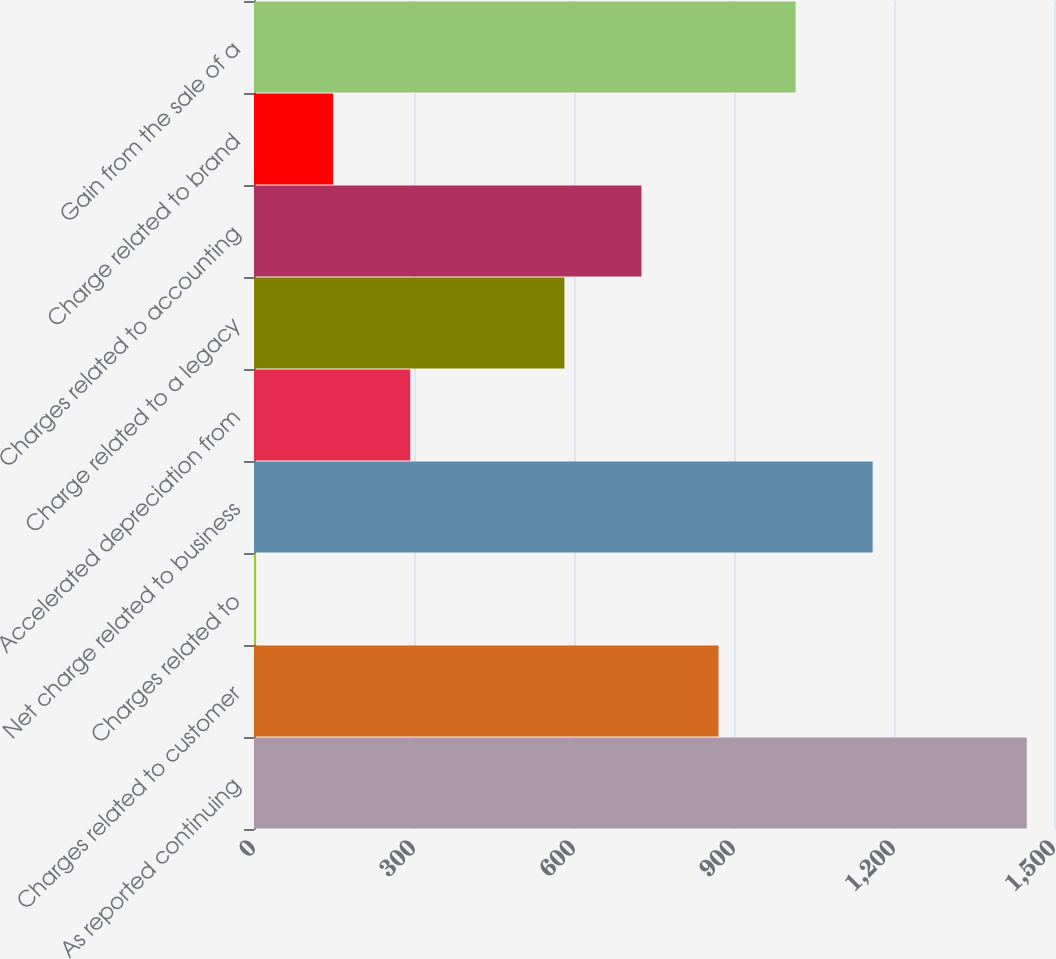Convert chart to OTSL. <chart><loc_0><loc_0><loc_500><loc_500><bar_chart><fcel>As reported continuing<fcel>Charges related to customer<fcel>Charges related to<fcel>Net charge related to business<fcel>Accelerated depreciation from<fcel>Charge related to a legacy<fcel>Charges related to accounting<fcel>Charge related to brand<fcel>Gain from the sale of a<nl><fcel>1449<fcel>871<fcel>4<fcel>1160<fcel>293<fcel>582<fcel>726.5<fcel>148.5<fcel>1015.5<nl></chart> 